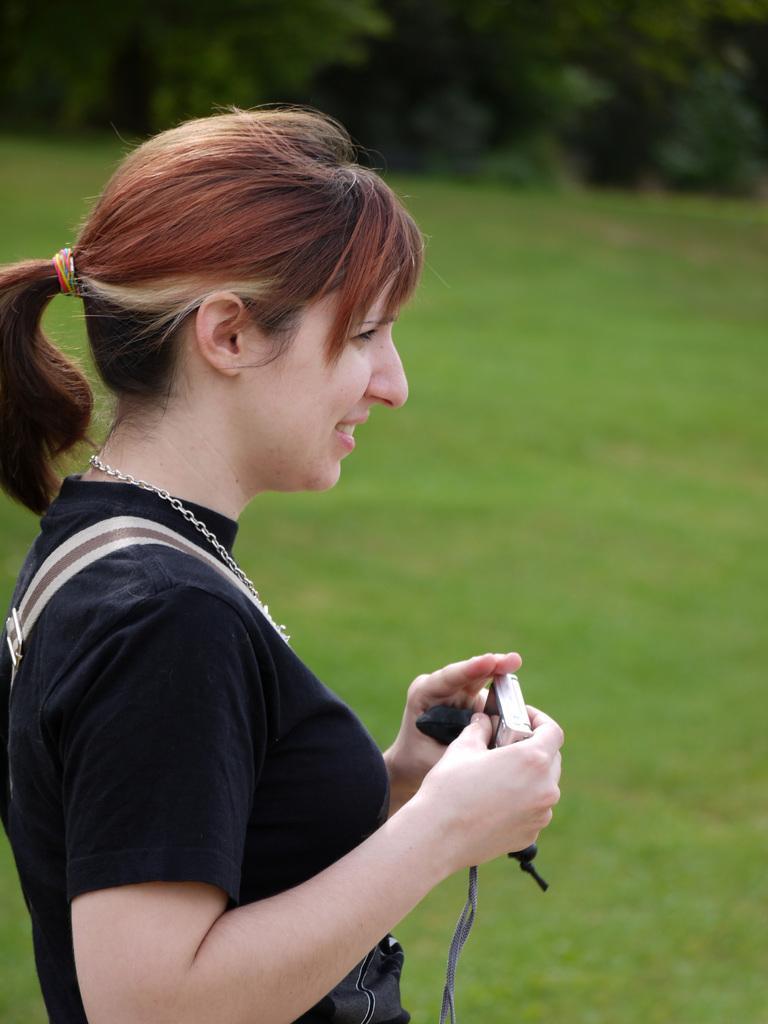Can you describe this image briefly? This image I can see a woman is standing and holding some object in hands. The woman is wearing black color clothes. In the background I can see the grass. The background of the image is blurred. 